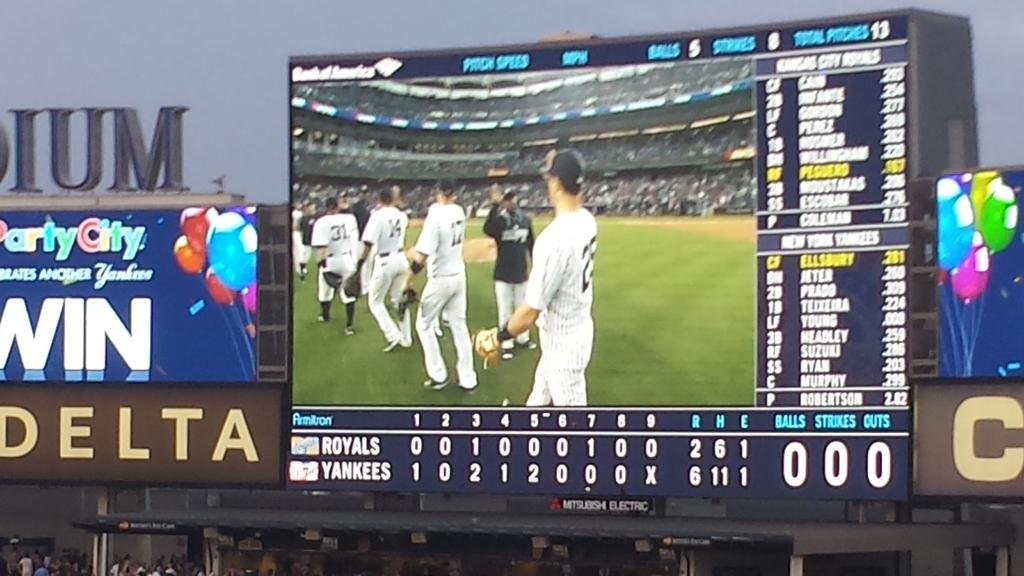<image>
Create a compact narrative representing the image presented. A scoreboard shows the Yankee players congratulating their teammates after the Yankees defeated the Royals 6-2. 